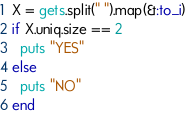Convert code to text. <code><loc_0><loc_0><loc_500><loc_500><_Ruby_>X = gets.split(" ").map(&:to_i)
if X.uniq.size == 2
  puts "YES"
else
  puts "NO"
end</code> 